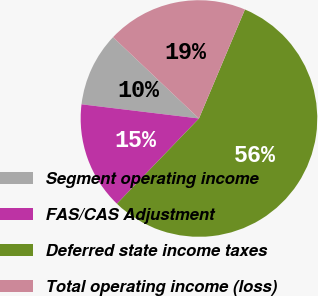Convert chart. <chart><loc_0><loc_0><loc_500><loc_500><pie_chart><fcel>Segment operating income<fcel>FAS/CAS Adjustment<fcel>Deferred state income taxes<fcel>Total operating income (loss)<nl><fcel>10.15%<fcel>14.72%<fcel>55.84%<fcel>19.29%<nl></chart> 